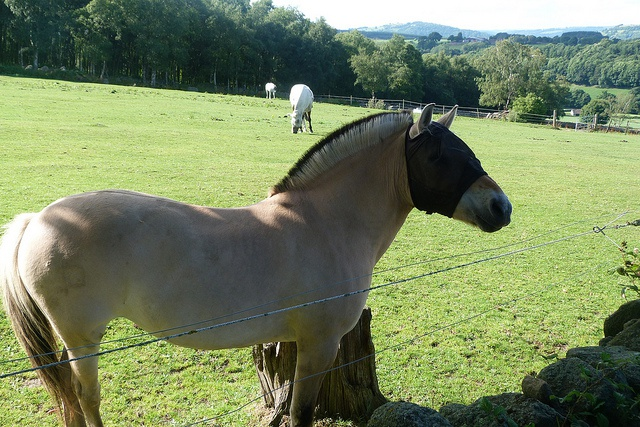Describe the objects in this image and their specific colors. I can see horse in black, gray, darkgreen, and ivory tones, horse in black, white, darkgray, and gray tones, and horse in black, white, darkgray, and gray tones in this image. 